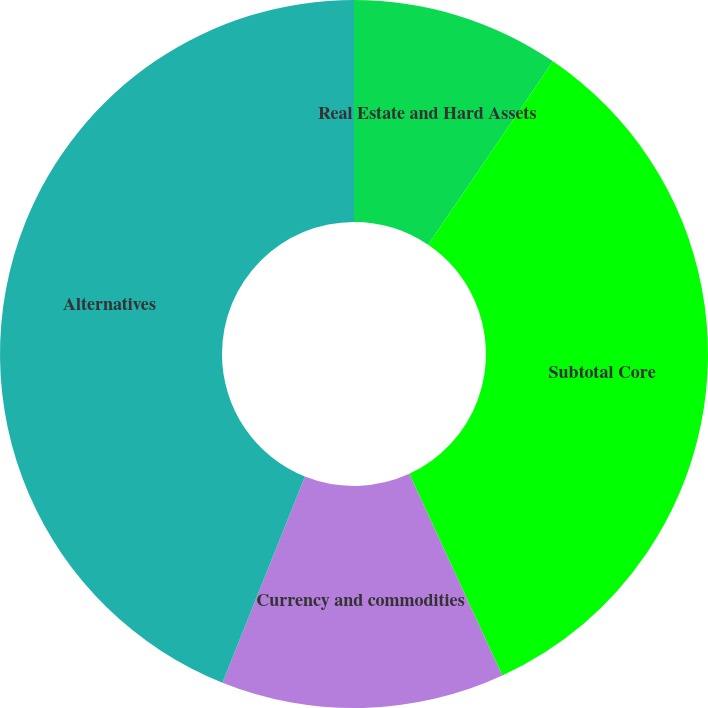<chart> <loc_0><loc_0><loc_500><loc_500><pie_chart><fcel>Real Estate and Hard Assets<fcel>Subtotal Core<fcel>Currency and commodities<fcel>Alternatives<nl><fcel>9.5%<fcel>33.62%<fcel>12.94%<fcel>43.94%<nl></chart> 